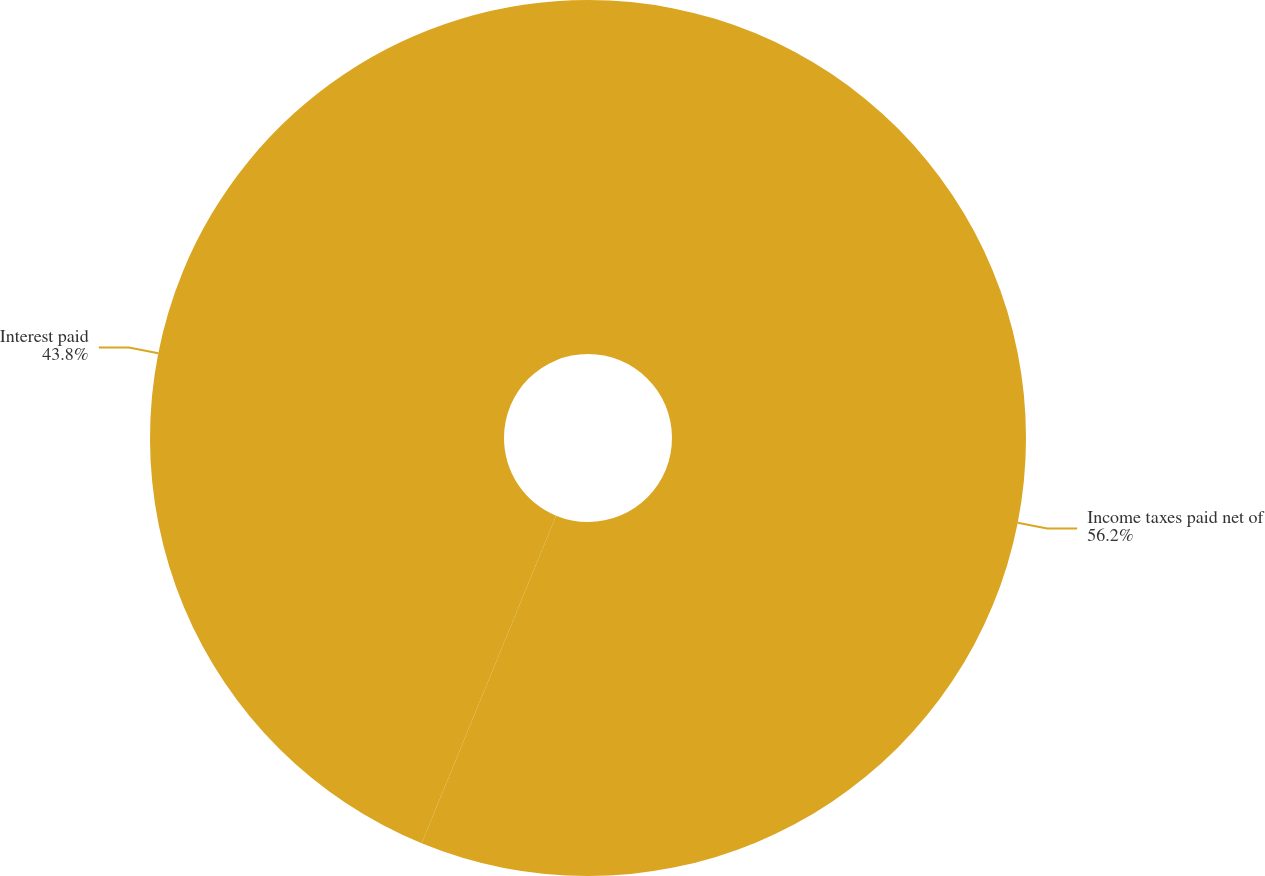Convert chart. <chart><loc_0><loc_0><loc_500><loc_500><pie_chart><fcel>Income taxes paid net of<fcel>Interest paid<nl><fcel>56.2%<fcel>43.8%<nl></chart> 